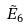<formula> <loc_0><loc_0><loc_500><loc_500>\tilde { E } _ { 6 }</formula> 